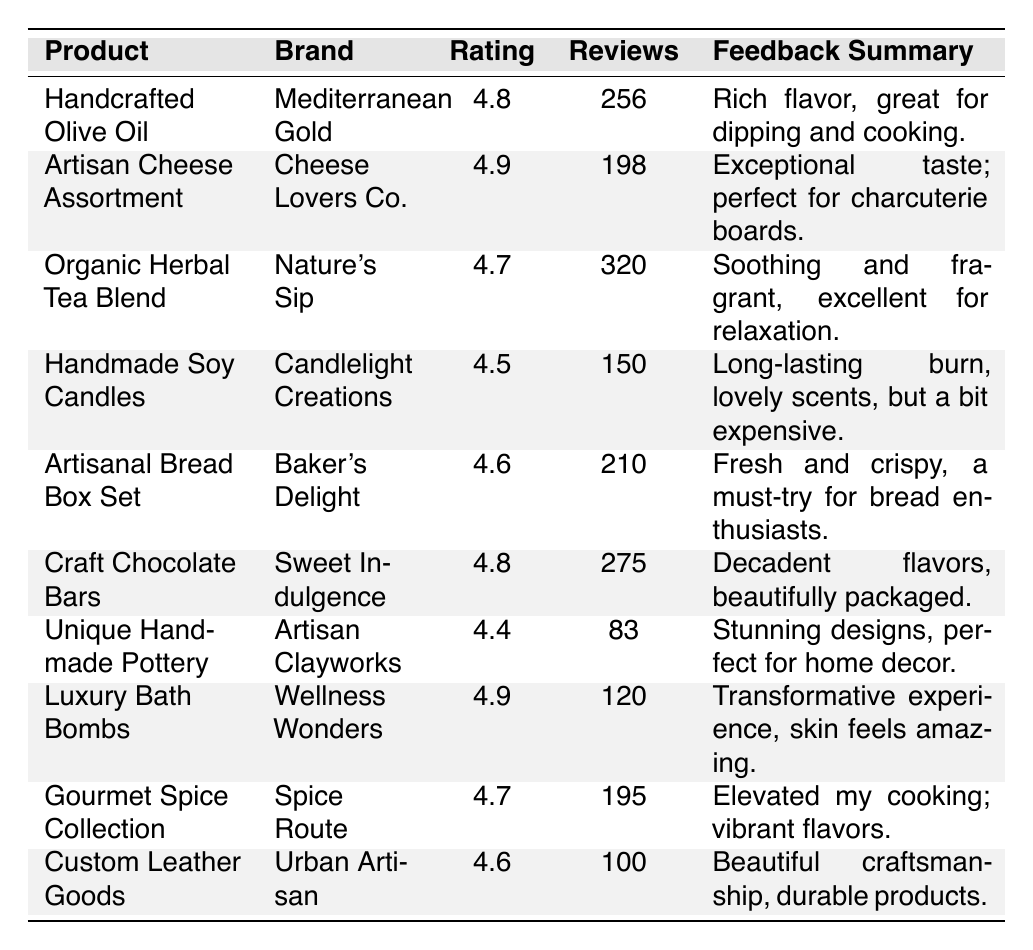What is the highest review rating among the products? The highest review rating can be found by scanning the "Review Rating" column. The highest value observed is 4.9.
Answer: 4.9 Which product has the most reviews? By examining the "Number of Reviews" column, we see "Organic Herbal Tea Blend" has the highest count at 320 reviews.
Answer: Organic Herbal Tea Blend Is there any product with a review rating below 4.5? We check the "Review Rating" column for values below 4.5. The "Unique Handmade Pottery" has a rating of 4.4, confirming the existence of such a product.
Answer: Yes How many products have a review rating of 4.6 or higher? We count the products with ratings of 4.6 and above: "Handcrafted Olive Oil," "Artisan Cheese Assortment," "Craft Chocolate Bars," "Gourmet Spice Collection," "Custom Leather Goods," and "Luxury Bath Bombs," making a total of 6.
Answer: 6 What is the average review rating of all products listed? We sum all the review ratings (4.8 + 4.9 + 4.7 + 4.5 + 4.6 + 4.8 + 4.4 + 4.9 + 4.7 + 4.6) = 47.9, divide by the total number of products (10), yielding an average of 4.79.
Answer: 4.79 Which brand has the lowest number of reviews for its product? We check the "Number of Reviews" and find "Unique Handmade Pottery" has the lowest at 83 reviews.
Answer: Artisan Clayworks Are there any products with a feedback summary mentioning "great for cooking"? Scanning the "Feedback Summary," the "Handcrafted Olive Oil" feedback mentions it's "great for dipping and cooking."
Answer: Yes What is the difference in the number of reviews between the product with the most reviews and the one with the least? We find "Organic Herbal Tea Blend" has 320 reviews (most) and "Unique Handmade Pottery" has 83 reviews (least). The difference is 320 - 83 = 237.
Answer: 237 How many products have a review rating of 4.5 or higher and less than 250 reviews? We check ratings of 4.5 or higher but with reviews less than 250. The qualifying products are "Handmade Soy Candles," "Artisanal Bread Box Set," and "Custom Leather Goods," resulting in 3 products.
Answer: 3 Which product received the feedback "perfect for charcuterie boards"? The feedback "perfect for charcuterie boards" corresponds to "Artisan Cheese Assortment."
Answer: Artisan Cheese Assortment 